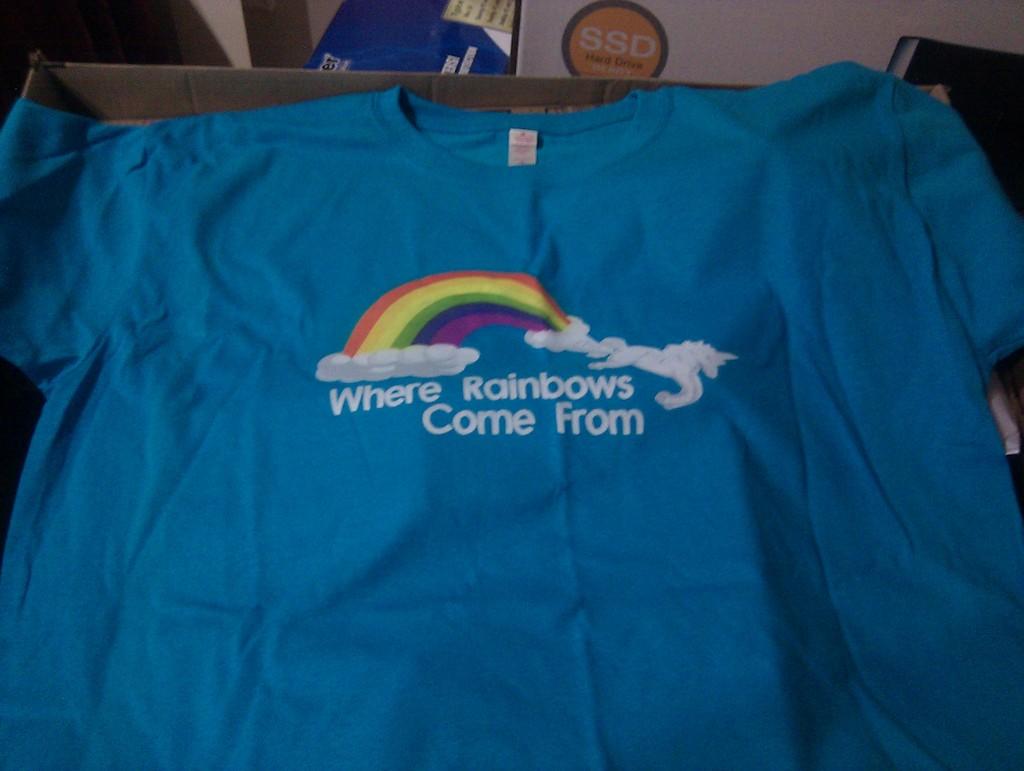What is on the shirt?
Your response must be concise. Where rainbows come from. What is written inside the yellow circle behind the tshirt?
Your response must be concise. Ssd. 